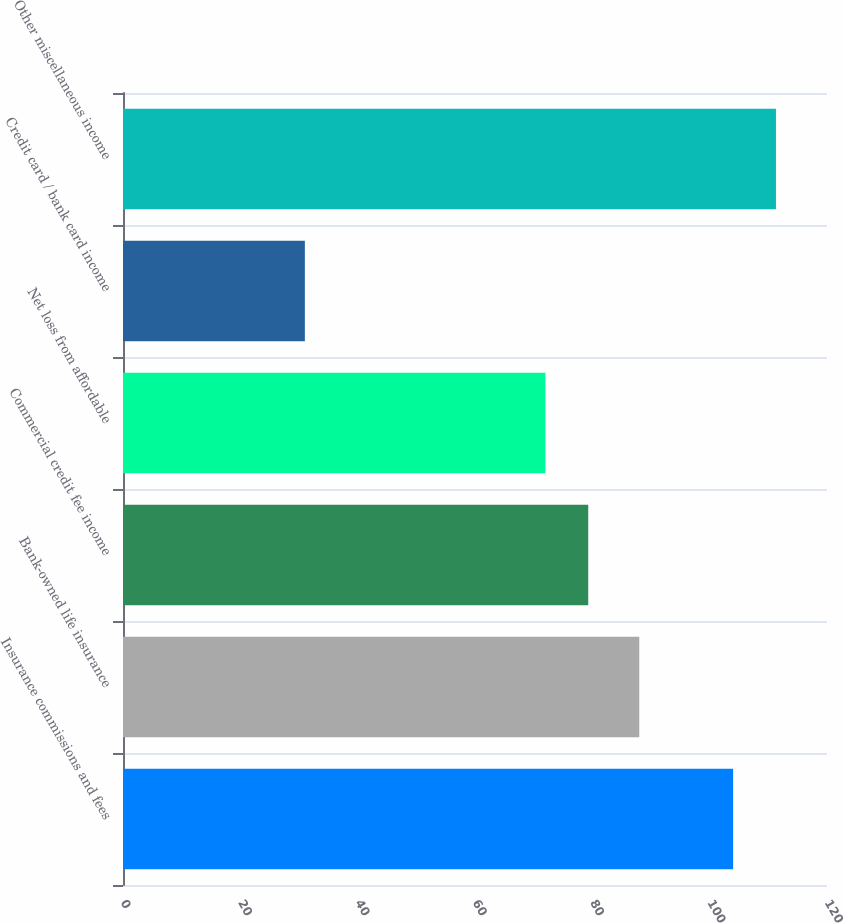<chart> <loc_0><loc_0><loc_500><loc_500><bar_chart><fcel>Insurance commissions and fees<fcel>Bank-owned life insurance<fcel>Commercial credit fee income<fcel>Net loss from affordable<fcel>Credit card / bank card income<fcel>Other miscellaneous income<nl><fcel>104<fcel>88<fcel>79.3<fcel>72<fcel>31<fcel>111.3<nl></chart> 